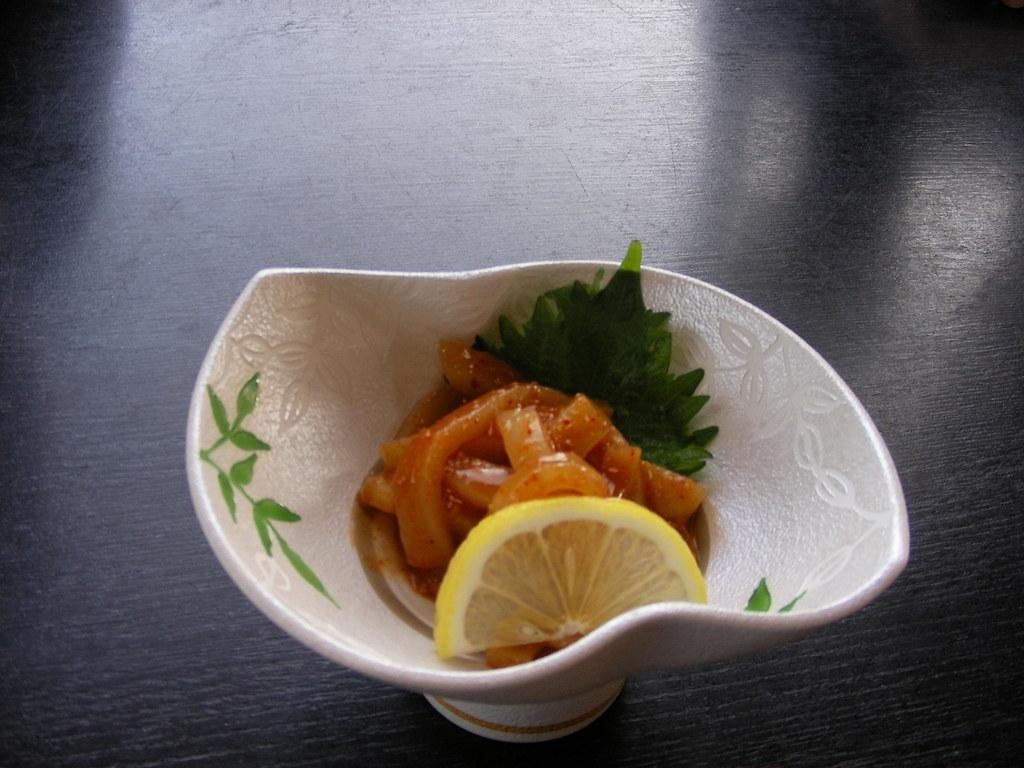What is in the bowl that is visible in the image? There are food items in a bowl in the image. What is the color of the surface on which the bowl is placed? The bowl is on a black color wooden surface. What type of cloud can be seen in the image? There is no cloud present in the image; it only features a bowl of food items on a black color wooden surface. 